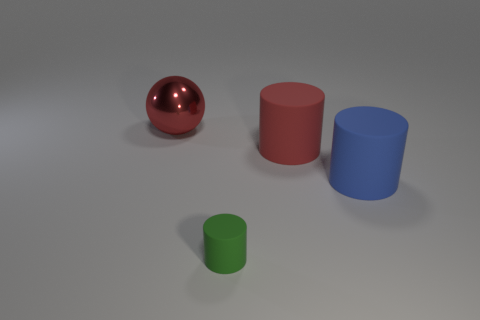Is there any other thing that is the same size as the green rubber object?
Give a very brief answer. No. What is the size of the blue rubber object that is the same shape as the green matte object?
Your response must be concise. Large. Is the number of big objects that are right of the green cylinder the same as the number of large gray cubes?
Provide a short and direct response. No. Do the red object right of the shiny ball and the blue rubber thing have the same shape?
Offer a very short reply. Yes. The big red rubber thing has what shape?
Provide a succinct answer. Cylinder. What material is the large red thing behind the big red thing in front of the red object on the left side of the small object?
Make the answer very short. Metal. What number of things are small red metallic blocks or green matte things?
Provide a short and direct response. 1. Do the red thing in front of the large shiny object and the big sphere have the same material?
Provide a short and direct response. No. What number of things are rubber cylinders that are to the left of the blue object or balls?
Provide a succinct answer. 3. There is a small cylinder that is made of the same material as the big blue thing; what color is it?
Ensure brevity in your answer.  Green. 